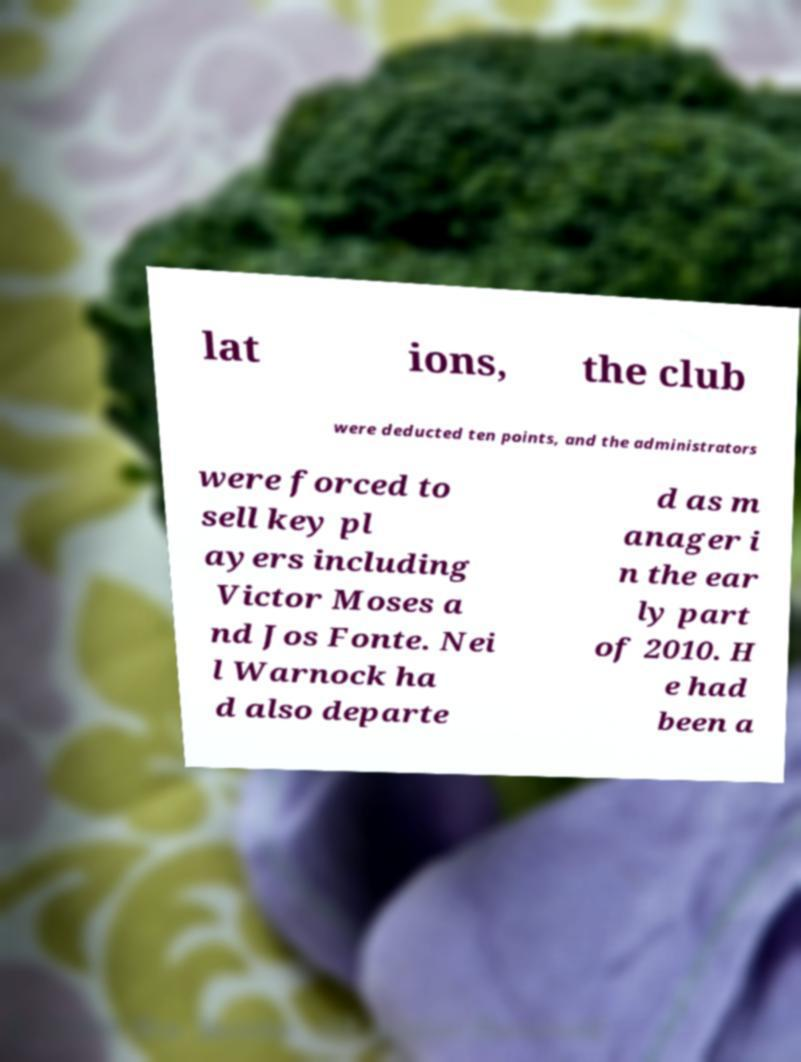Can you accurately transcribe the text from the provided image for me? lat ions, the club were deducted ten points, and the administrators were forced to sell key pl ayers including Victor Moses a nd Jos Fonte. Nei l Warnock ha d also departe d as m anager i n the ear ly part of 2010. H e had been a 